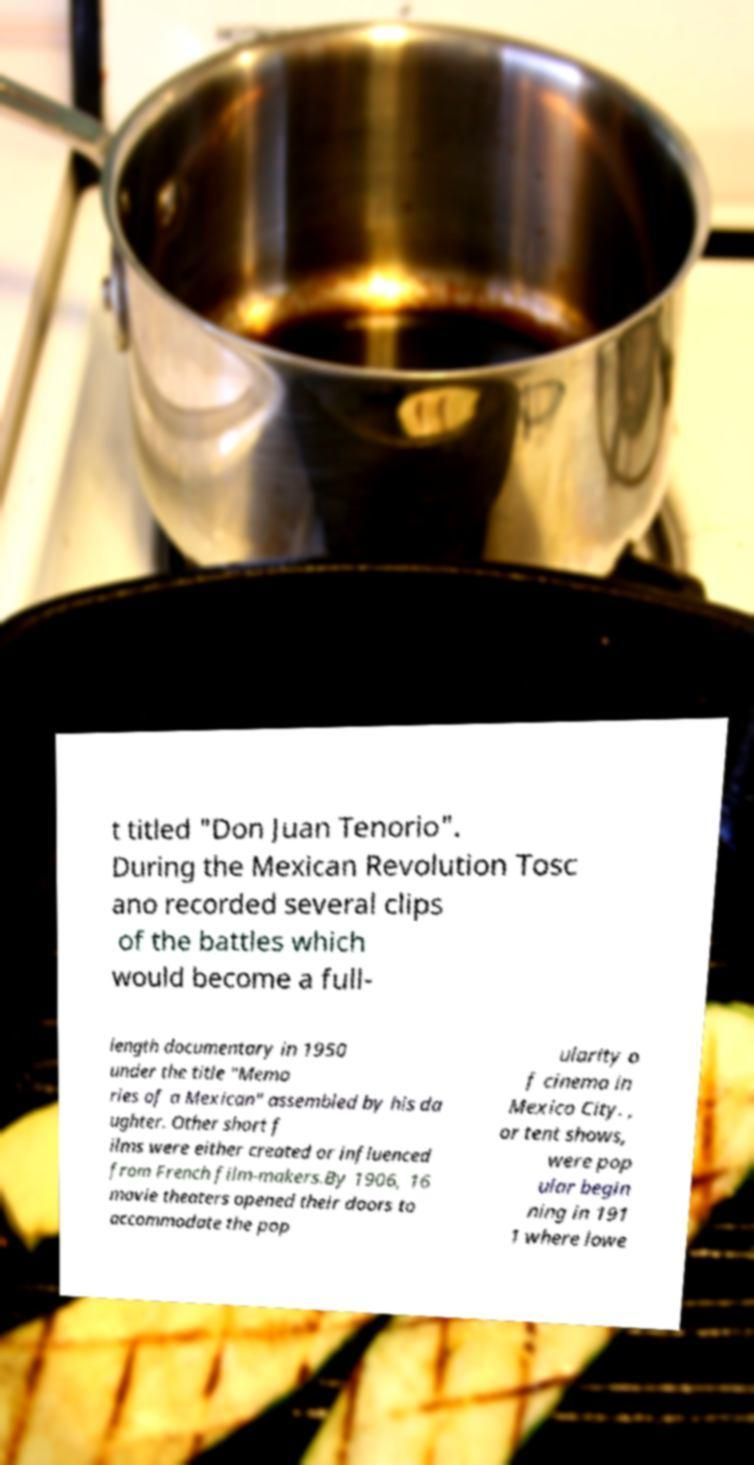Can you accurately transcribe the text from the provided image for me? t titled "Don Juan Tenorio". During the Mexican Revolution Tosc ano recorded several clips of the battles which would become a full- length documentary in 1950 under the title "Memo ries of a Mexican" assembled by his da ughter. Other short f ilms were either created or influenced from French film-makers.By 1906, 16 movie theaters opened their doors to accommodate the pop ularity o f cinema in Mexico City. , or tent shows, were pop ular begin ning in 191 1 where lowe 